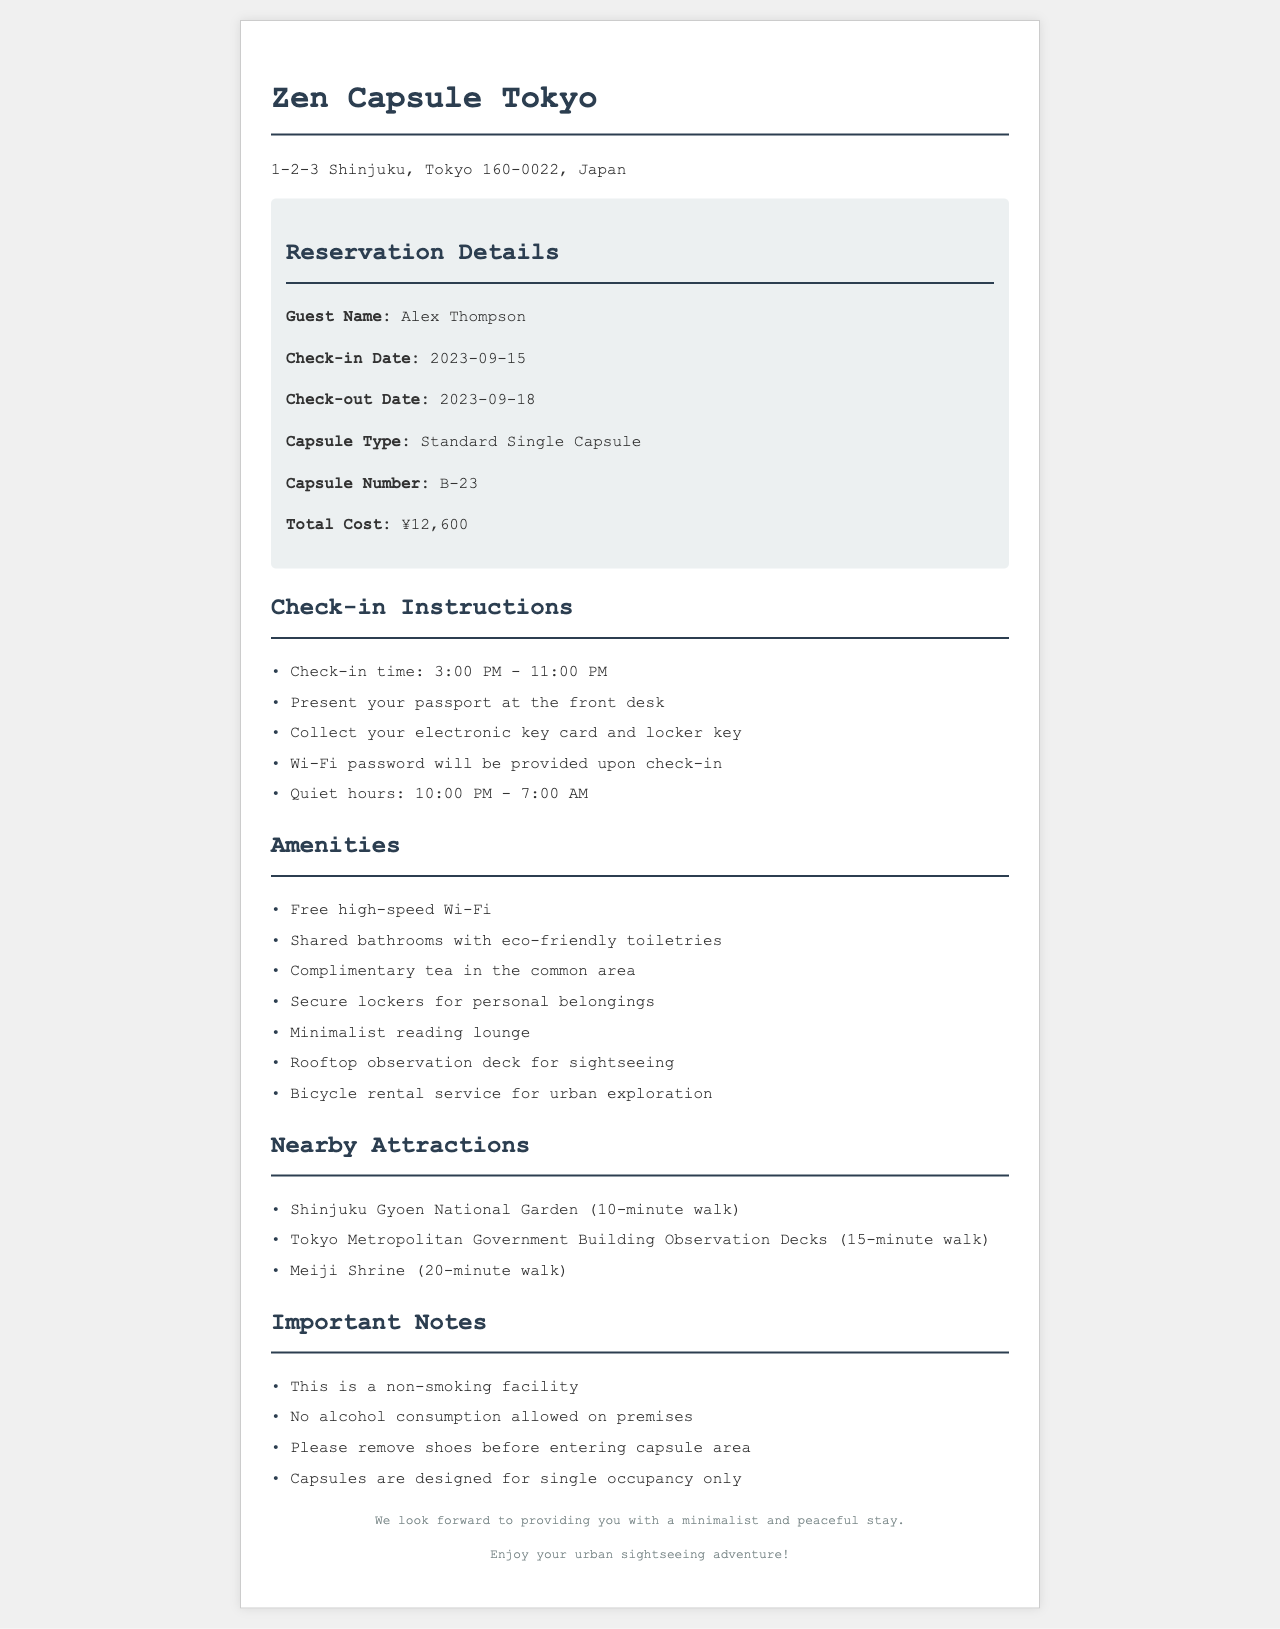What is the guest name? The guest name is provided in the reservation details section of the document.
Answer: Alex Thompson What are the check-in and check-out dates? The check-in and check-out dates are located in the reservation details, indicating when the guest will arrive and depart.
Answer: 2023-09-15 and 2023-09-18 What type of capsule is reserved? This refers to the type of accommodation the guest will be staying in, mentioned in the reservation details.
Answer: Standard Single Capsule What is the capsule number? The capsule number is specified in the reservation details for identification during the stay.
Answer: B-23 What time does check-in begin? Check-in time information is explicitly mentioned in the instructions section of the document.
Answer: 3:00 PM How many nearby attractions are listed? The number of nearby attractions can be counted in the attractions section of the document.
Answer: 3 What is provided in the common area? Amenities offered at the hotel include details about shared facilities available for guests.
Answer: Complimentary tea What are the quiet hours? The document specifies the hours during which guests are expected to keep noise to a minimum.
Answer: 10:00 PM - 7:00 AM Is this a smoking facility? The document contains explicit information regarding smoking in the establishment in the important notes section.
Answer: No 